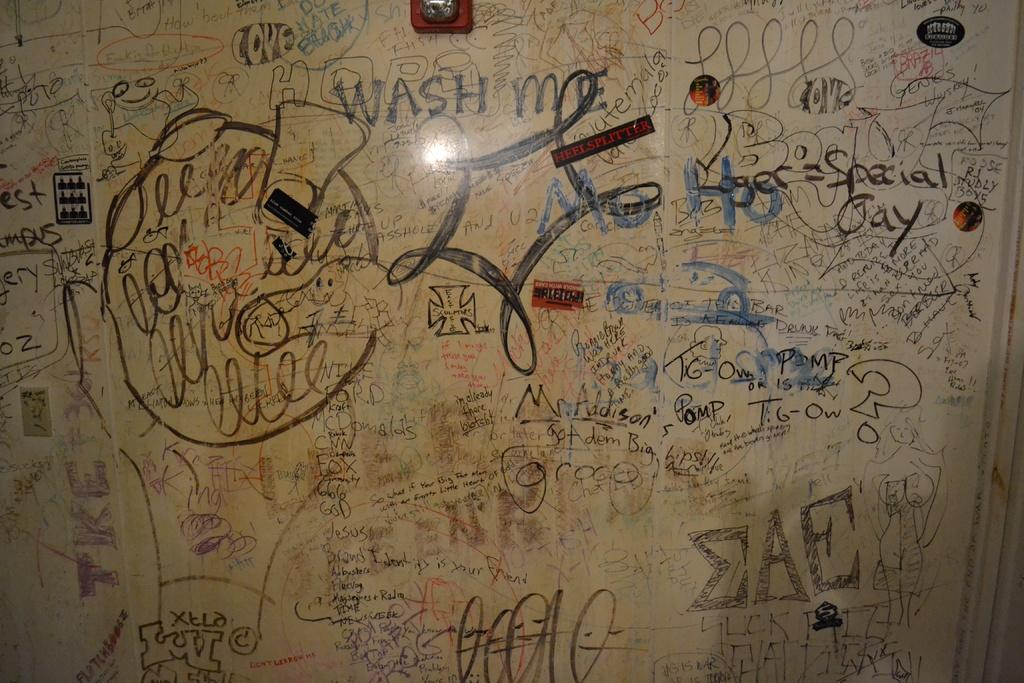<image>
Provide a brief description of the given image. Board with random writing on it and the word "wash" in the middle. 